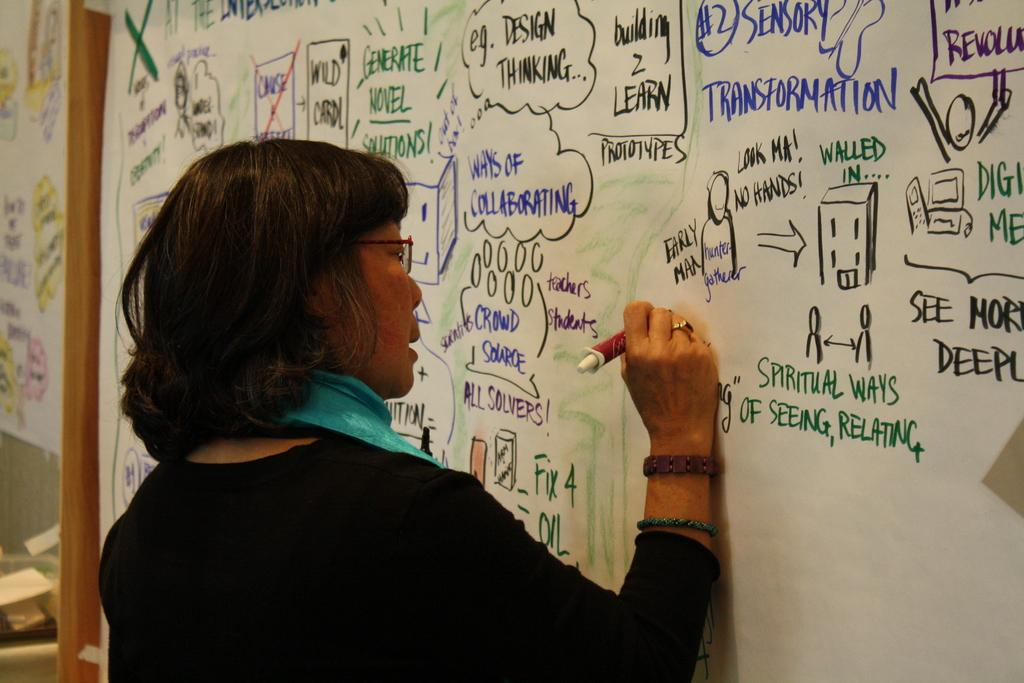Provide a one-sentence caption for the provided image. A woman writes on a white board besides green writing that states, "Spiritual Ways.". 